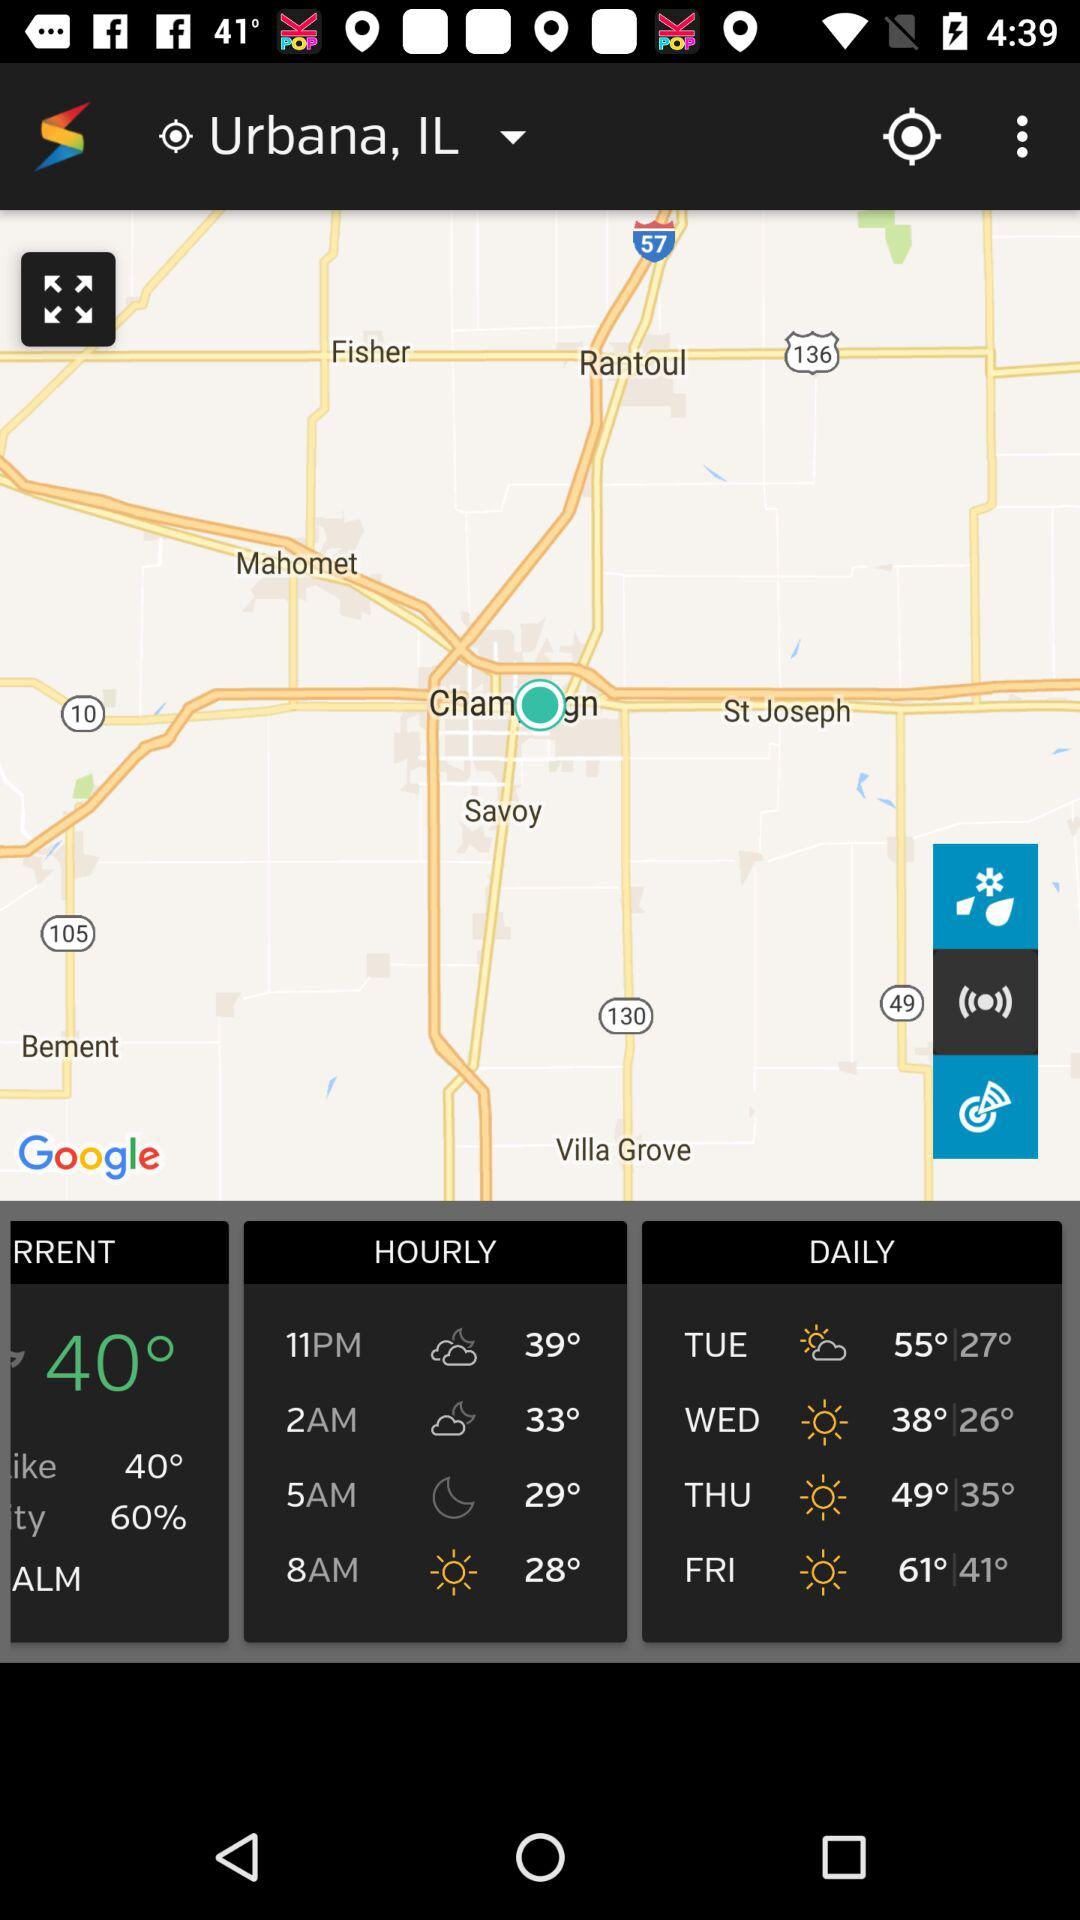What is the minimum temperature on Wednesday? The minimum temperature on Wednesday is 26°. 